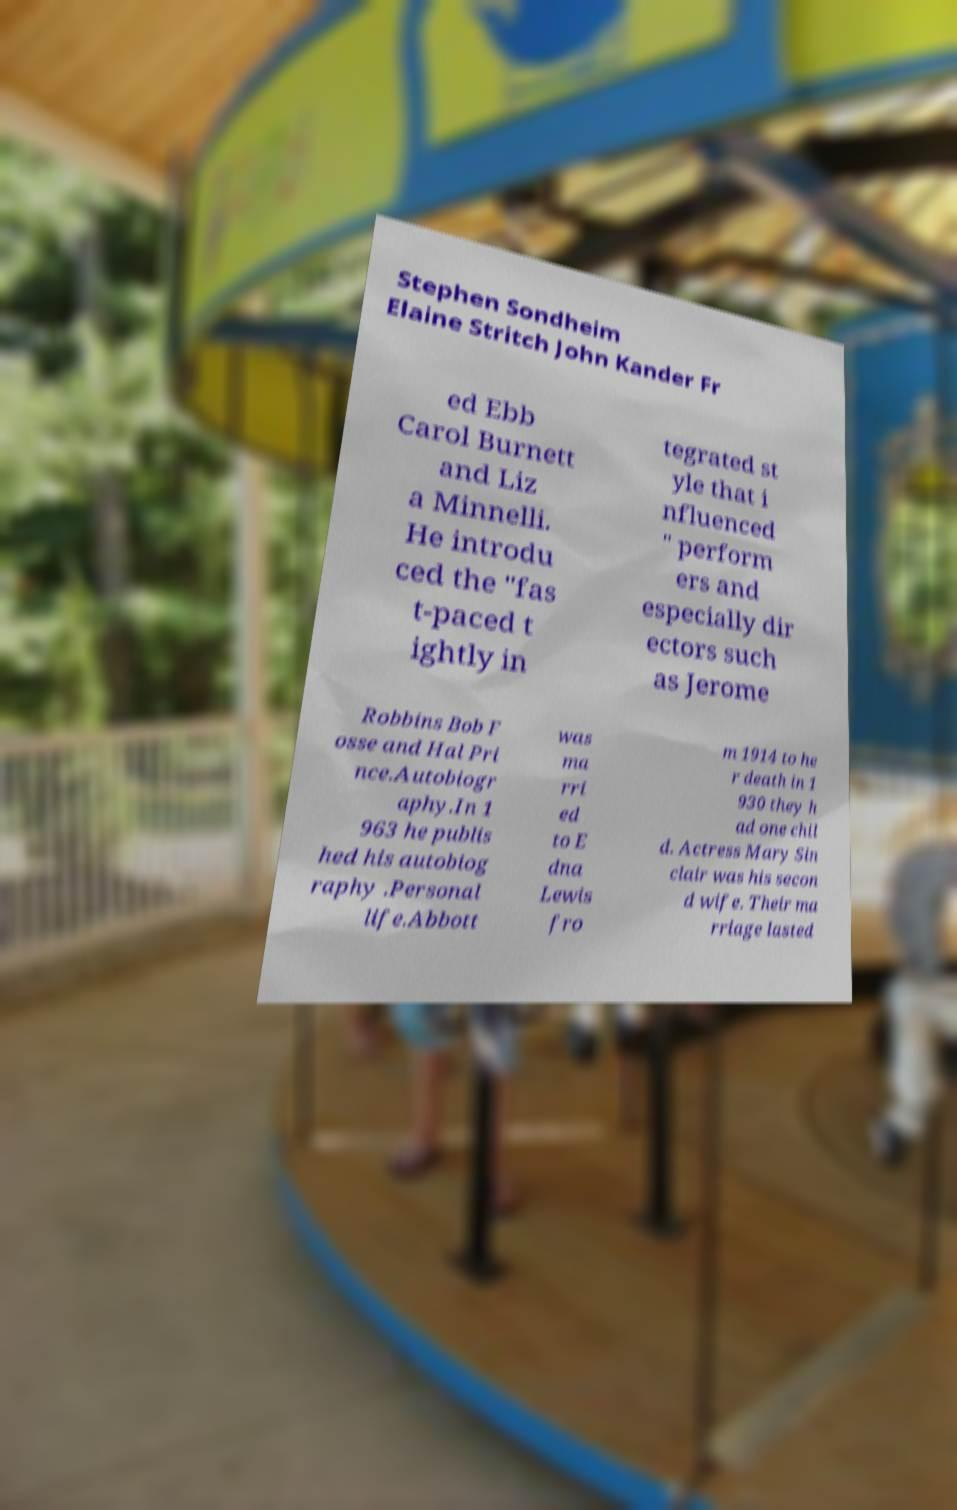What messages or text are displayed in this image? I need them in a readable, typed format. Stephen Sondheim Elaine Stritch John Kander Fr ed Ebb Carol Burnett and Liz a Minnelli. He introdu ced the "fas t-paced t ightly in tegrated st yle that i nfluenced " perform ers and especially dir ectors such as Jerome Robbins Bob F osse and Hal Pri nce.Autobiogr aphy.In 1 963 he publis hed his autobiog raphy .Personal life.Abbott was ma rri ed to E dna Lewis fro m 1914 to he r death in 1 930 they h ad one chil d. Actress Mary Sin clair was his secon d wife. Their ma rriage lasted 